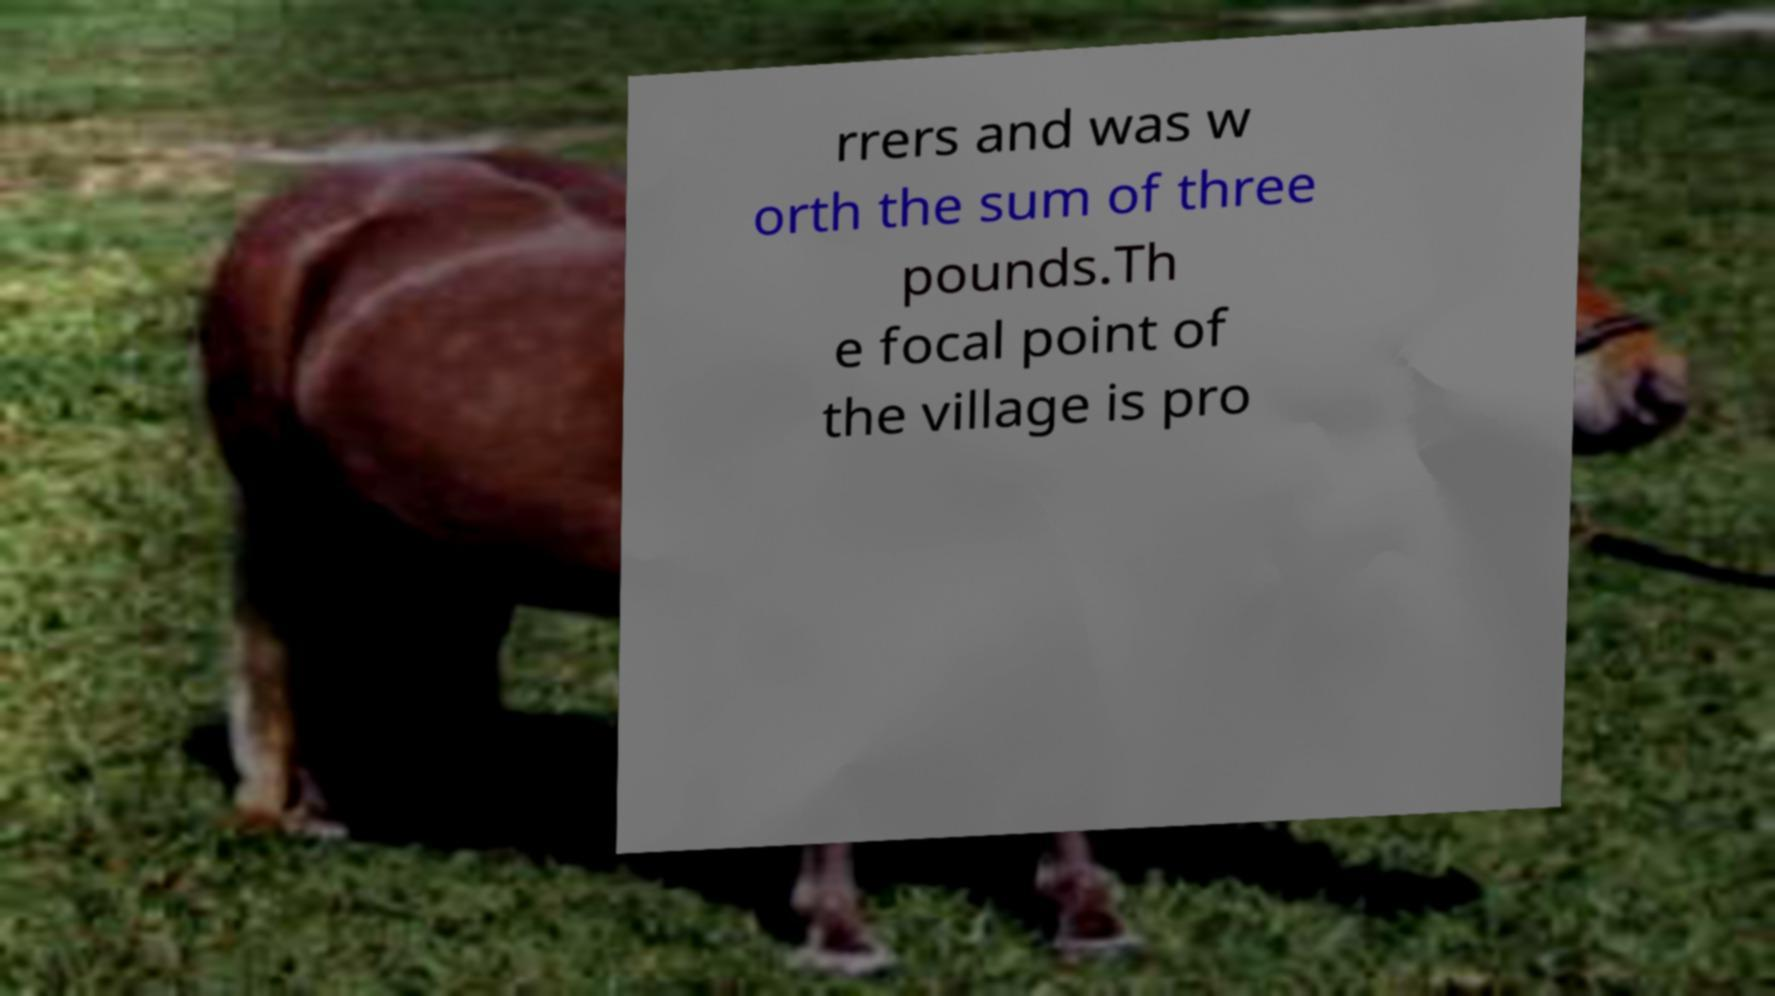Could you extract and type out the text from this image? rrers and was w orth the sum of three pounds.Th e focal point of the village is pro 